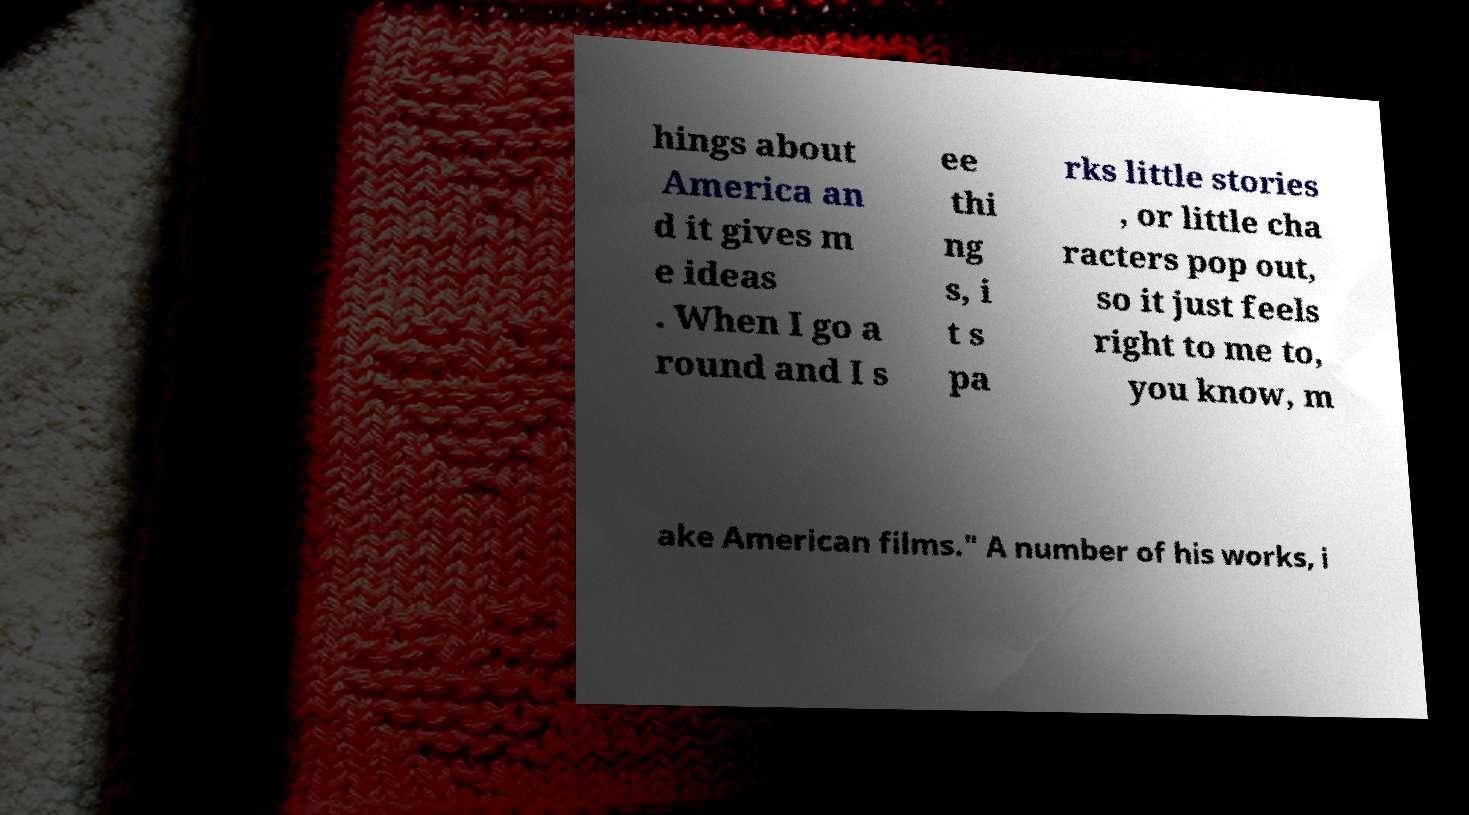For documentation purposes, I need the text within this image transcribed. Could you provide that? hings about America an d it gives m e ideas . When I go a round and I s ee thi ng s, i t s pa rks little stories , or little cha racters pop out, so it just feels right to me to, you know, m ake American films." A number of his works, i 